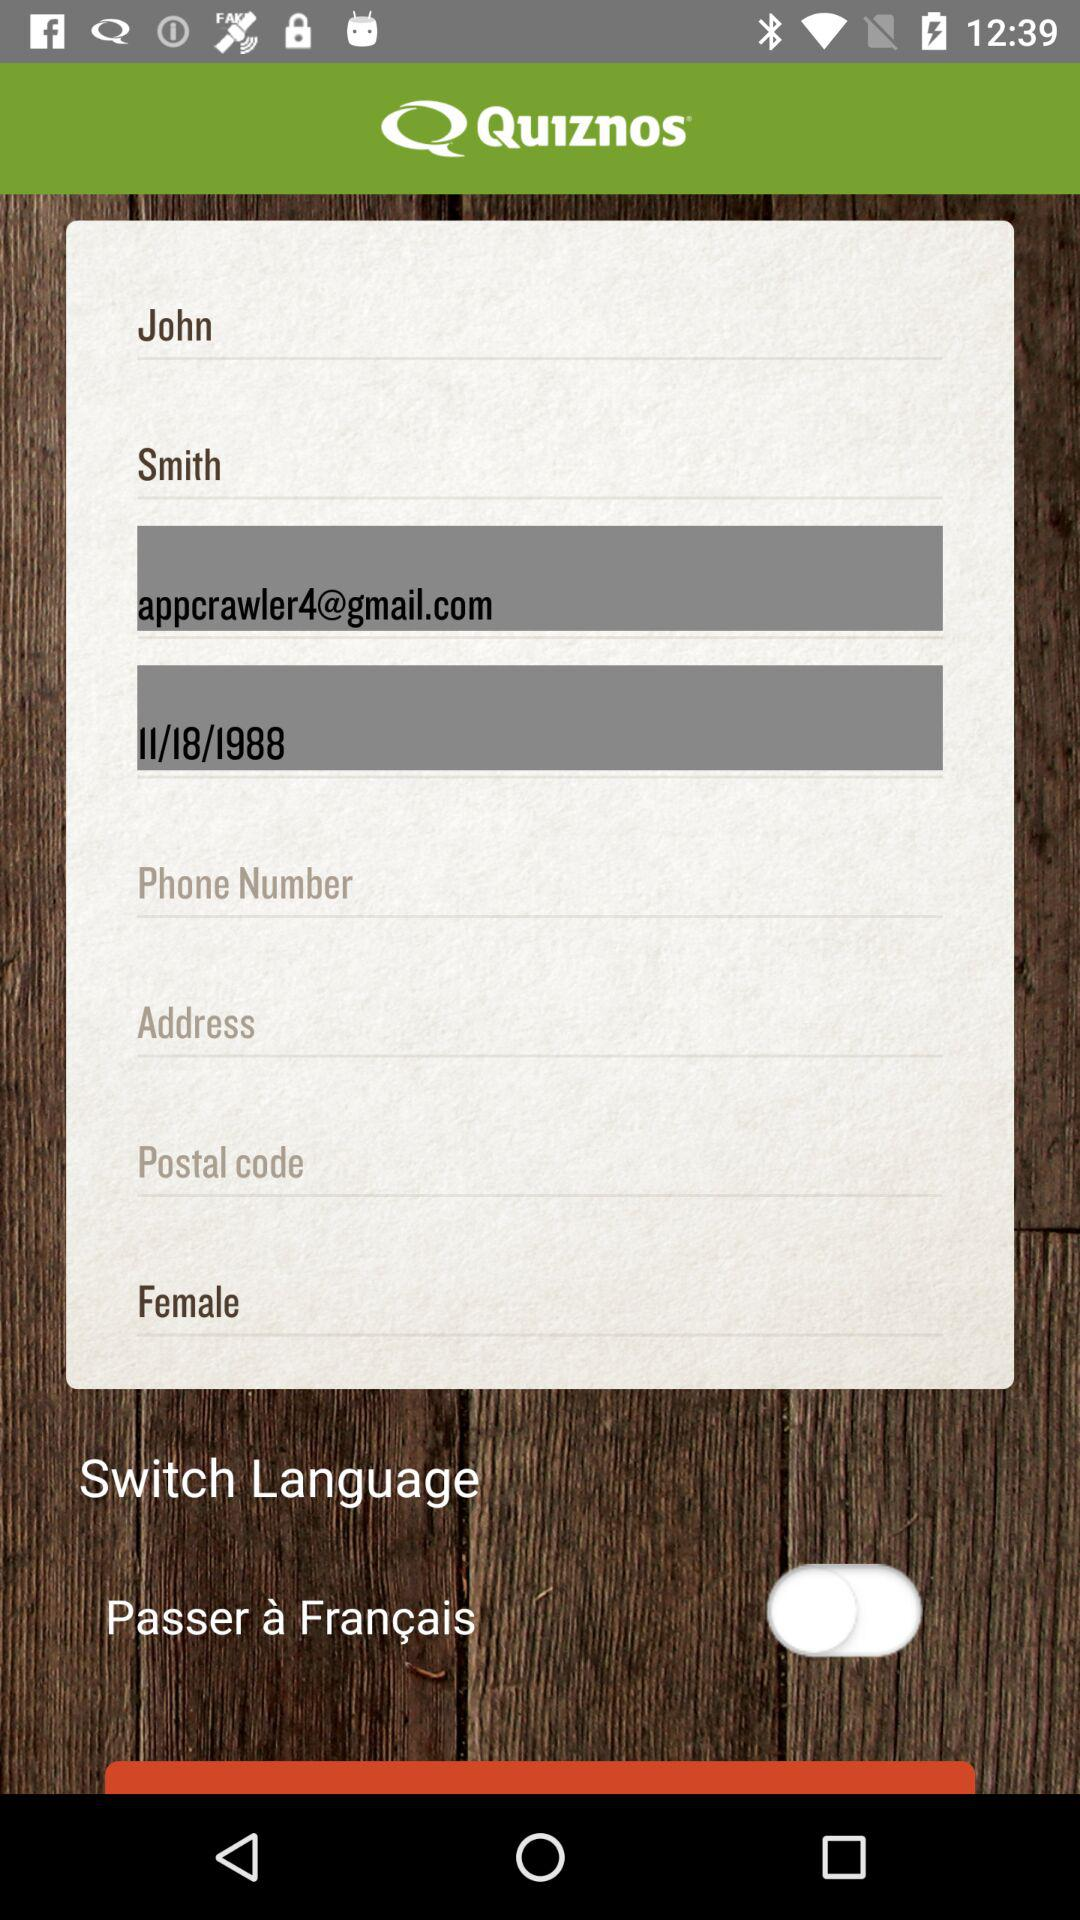What is the current status of the "Passer à Français" setting? The current status is "off". 